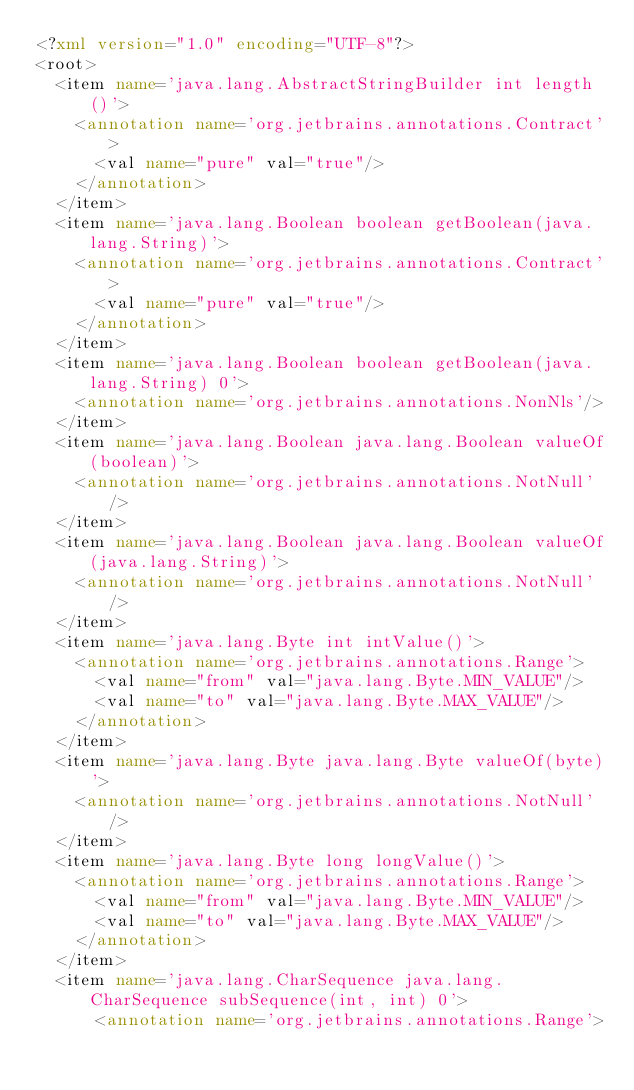Convert code to text. <code><loc_0><loc_0><loc_500><loc_500><_XML_><?xml version="1.0" encoding="UTF-8"?>
<root>
  <item name='java.lang.AbstractStringBuilder int length()'>
    <annotation name='org.jetbrains.annotations.Contract'>
      <val name="pure" val="true"/>
    </annotation>
  </item>
  <item name='java.lang.Boolean boolean getBoolean(java.lang.String)'>
    <annotation name='org.jetbrains.annotations.Contract'>
      <val name="pure" val="true"/>
    </annotation>
  </item>
  <item name='java.lang.Boolean boolean getBoolean(java.lang.String) 0'>
    <annotation name='org.jetbrains.annotations.NonNls'/>
  </item>
  <item name='java.lang.Boolean java.lang.Boolean valueOf(boolean)'>
    <annotation name='org.jetbrains.annotations.NotNull'/>
  </item>
  <item name='java.lang.Boolean java.lang.Boolean valueOf(java.lang.String)'>
    <annotation name='org.jetbrains.annotations.NotNull'/>
  </item>
  <item name='java.lang.Byte int intValue()'>
    <annotation name='org.jetbrains.annotations.Range'>
      <val name="from" val="java.lang.Byte.MIN_VALUE"/>
      <val name="to" val="java.lang.Byte.MAX_VALUE"/>
    </annotation>
  </item>
  <item name='java.lang.Byte java.lang.Byte valueOf(byte)'>
    <annotation name='org.jetbrains.annotations.NotNull'/>
  </item>
  <item name='java.lang.Byte long longValue()'>
    <annotation name='org.jetbrains.annotations.Range'>
      <val name="from" val="java.lang.Byte.MIN_VALUE"/>
      <val name="to" val="java.lang.Byte.MAX_VALUE"/>
    </annotation>
  </item>
  <item name='java.lang.CharSequence java.lang.CharSequence subSequence(int, int) 0'>
      <annotation name='org.jetbrains.annotations.Range'></code> 